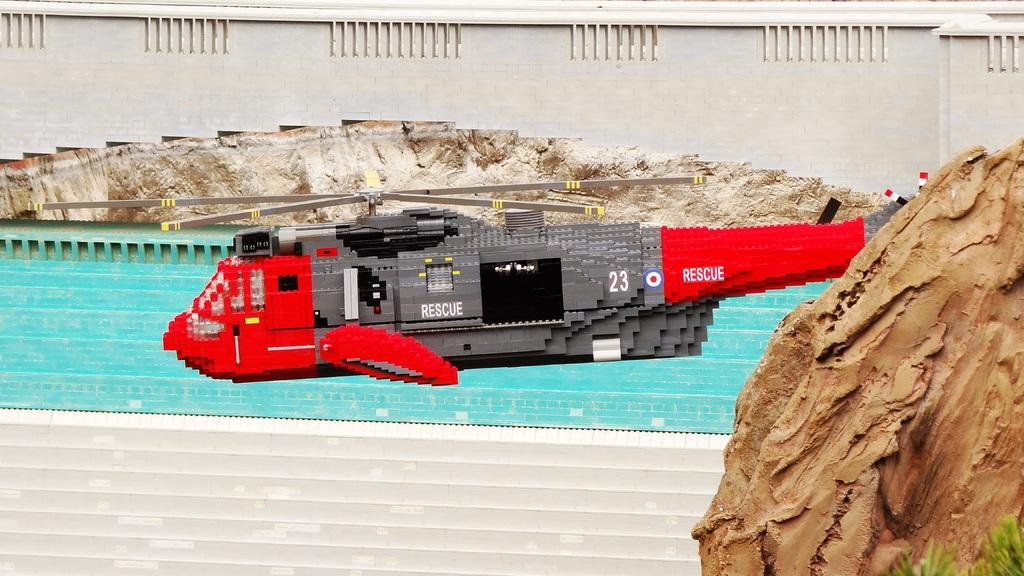In one or two sentences, can you explain what this image depicts? In this picture I can see a toy helicopter, there is a rock, a bridge and there is water. 